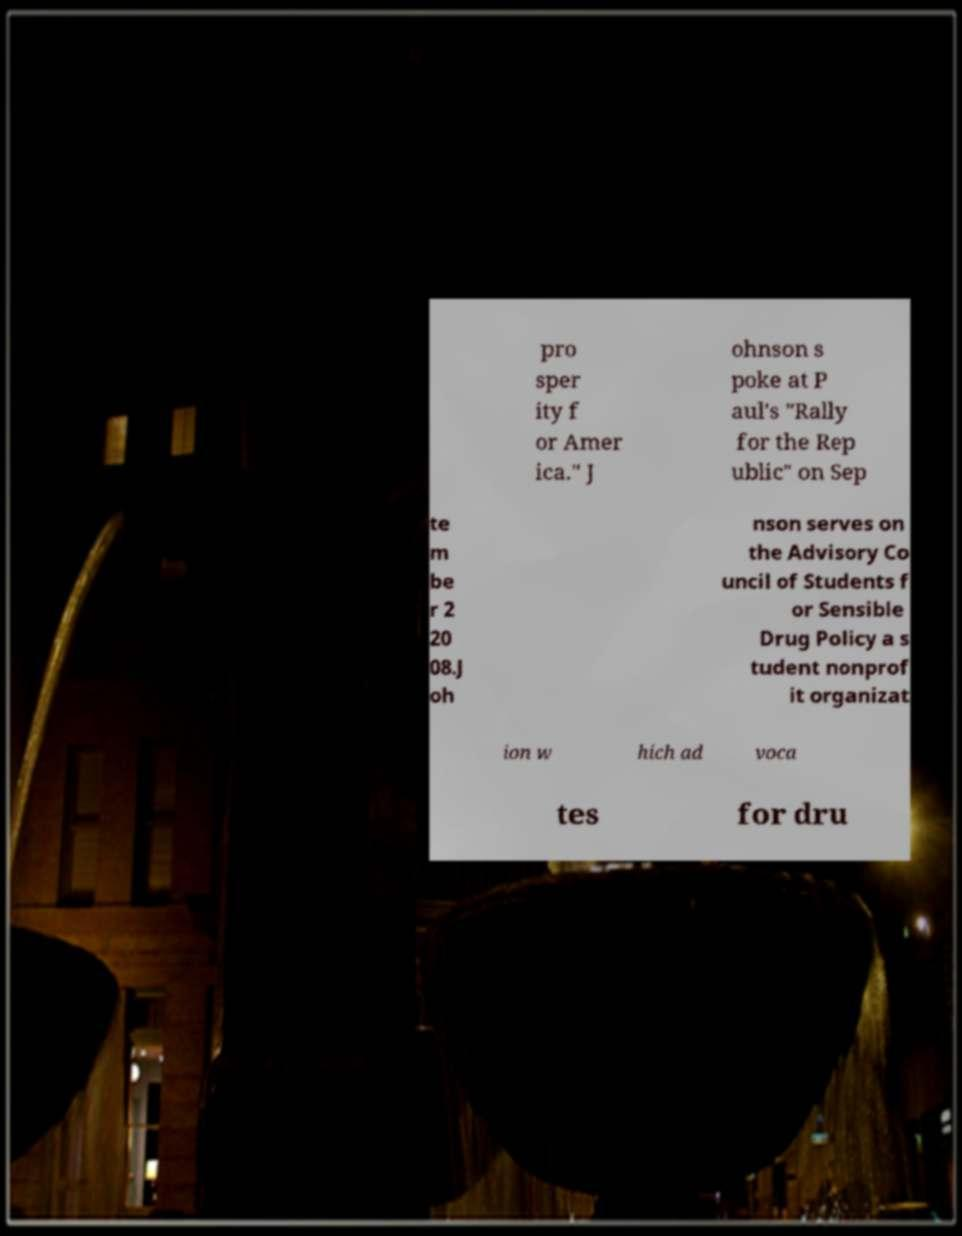Could you assist in decoding the text presented in this image and type it out clearly? pro sper ity f or Amer ica." J ohnson s poke at P aul's "Rally for the Rep ublic" on Sep te m be r 2 20 08.J oh nson serves on the Advisory Co uncil of Students f or Sensible Drug Policy a s tudent nonprof it organizat ion w hich ad voca tes for dru 